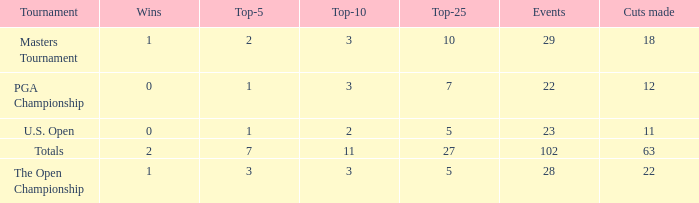How many vuts made for a player with 2 wins and under 7 top 5s? None. 